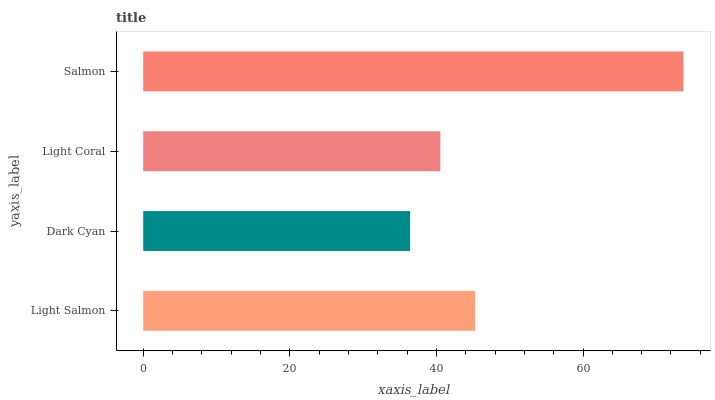Is Dark Cyan the minimum?
Answer yes or no. Yes. Is Salmon the maximum?
Answer yes or no. Yes. Is Light Coral the minimum?
Answer yes or no. No. Is Light Coral the maximum?
Answer yes or no. No. Is Light Coral greater than Dark Cyan?
Answer yes or no. Yes. Is Dark Cyan less than Light Coral?
Answer yes or no. Yes. Is Dark Cyan greater than Light Coral?
Answer yes or no. No. Is Light Coral less than Dark Cyan?
Answer yes or no. No. Is Light Salmon the high median?
Answer yes or no. Yes. Is Light Coral the low median?
Answer yes or no. Yes. Is Light Coral the high median?
Answer yes or no. No. Is Salmon the low median?
Answer yes or no. No. 